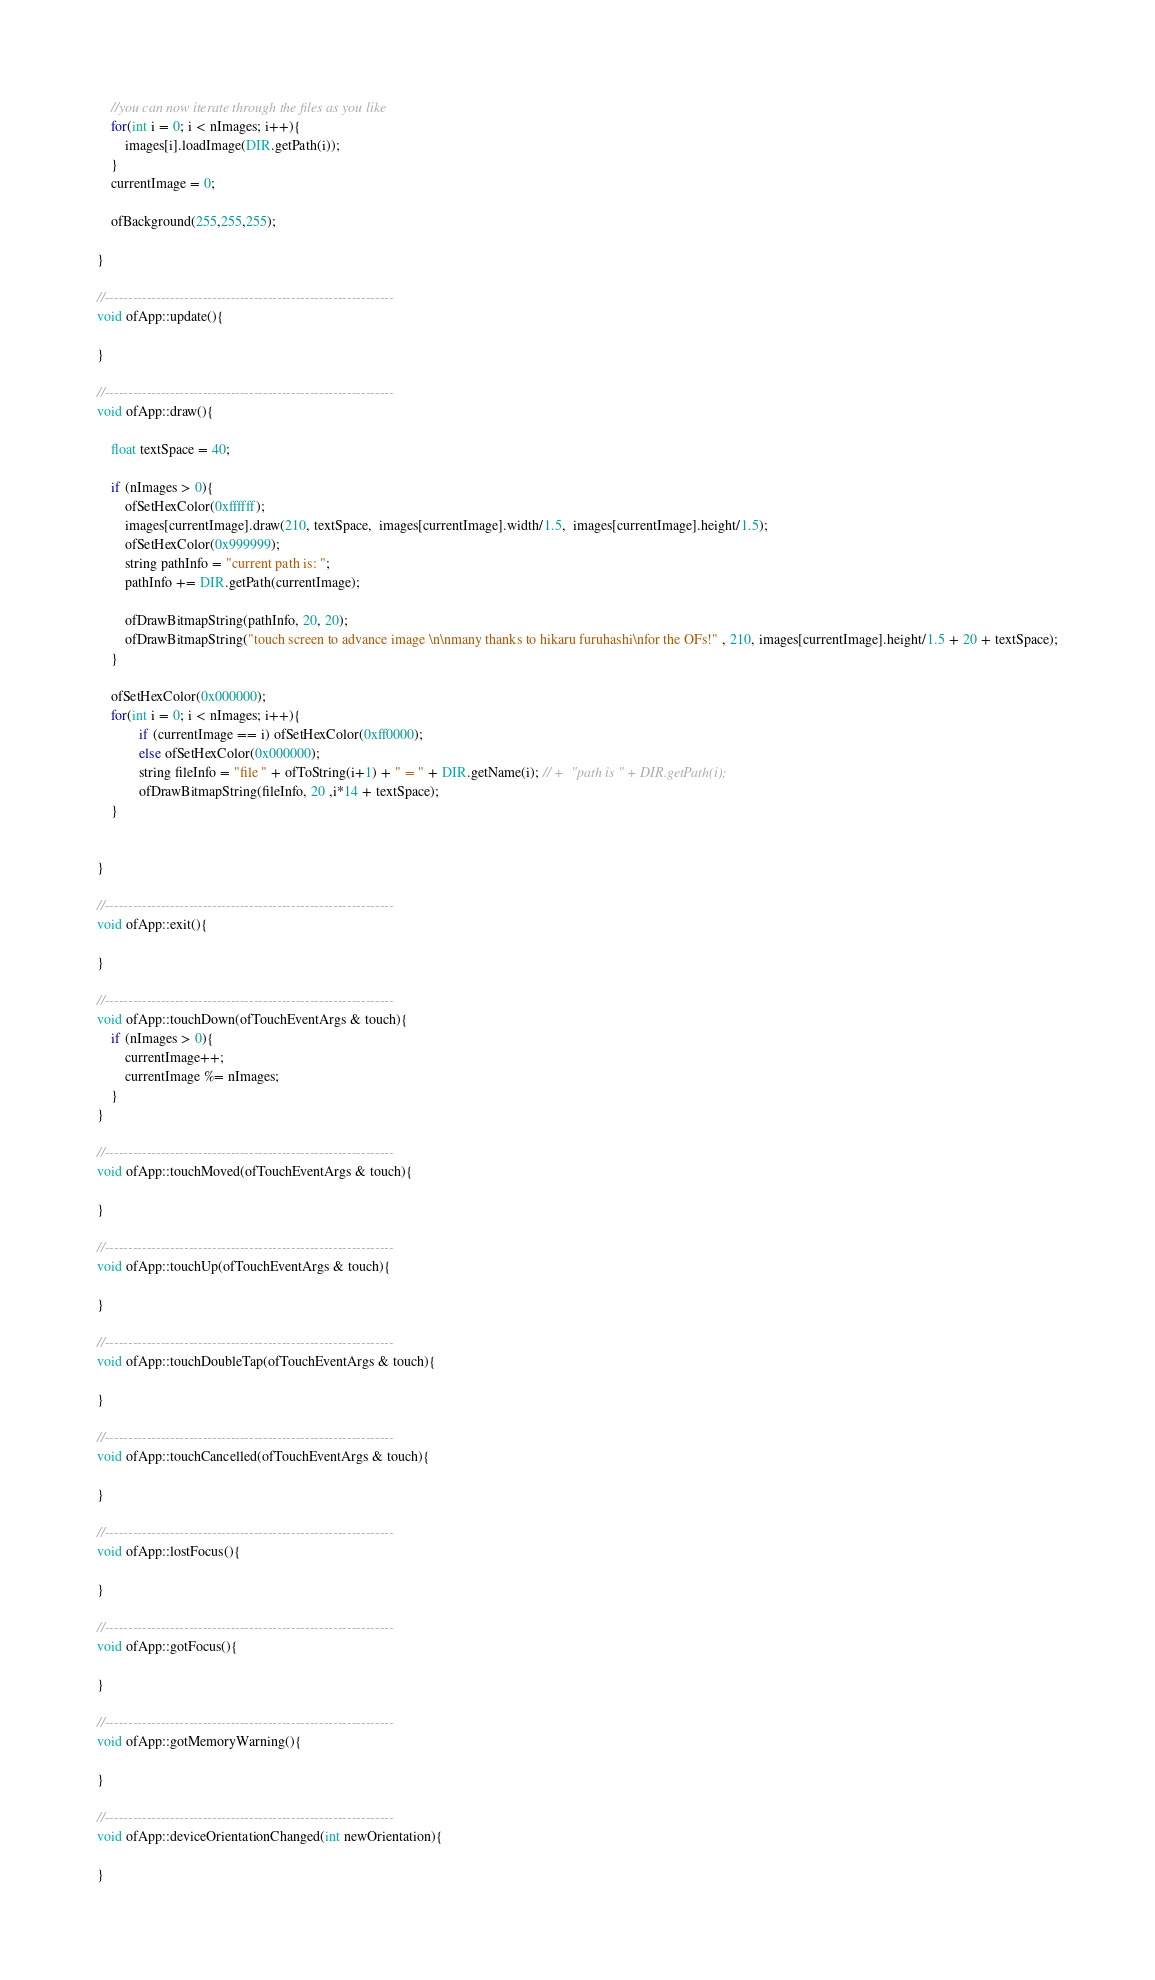Convert code to text. <code><loc_0><loc_0><loc_500><loc_500><_ObjectiveC_>    //you can now iterate through the files as you like
    for(int i = 0; i < nImages; i++){
		images[i].loadImage(DIR.getPath(i));
    }
    currentImage = 0;

    ofBackground(255,255,255);

}

//--------------------------------------------------------------
void ofApp::update(){

}

//--------------------------------------------------------------
void ofApp::draw(){
	
	float textSpace = 40;
	
    if (nImages > 0){
        ofSetHexColor(0xffffff);
        images[currentImage].draw(210, textSpace,  images[currentImage].width/1.5,  images[currentImage].height/1.5);
        ofSetHexColor(0x999999);
        string pathInfo = "current path is: ";
		pathInfo += DIR.getPath(currentImage);
				
		ofDrawBitmapString(pathInfo, 20, 20);
		ofDrawBitmapString("touch screen to advance image \n\nmany thanks to hikaru furuhashi\nfor the OFs!" , 210, images[currentImage].height/1.5 + 20 + textSpace);
    }

    ofSetHexColor(0x000000);
    for(int i = 0; i < nImages; i++){
            if (currentImage == i) ofSetHexColor(0xff0000);
            else ofSetHexColor(0x000000);
            string fileInfo = "file " + ofToString(i+1) + " = " + DIR.getName(i); // +  "path is " + DIR.getPath(i);
            ofDrawBitmapString(fileInfo, 20 ,i*14 + textSpace);
    }

	
}

//--------------------------------------------------------------
void ofApp::exit(){

}

//--------------------------------------------------------------
void ofApp::touchDown(ofTouchEventArgs & touch){
	if (nImages > 0){
		currentImage++;
		currentImage %= nImages;
	}
}

//--------------------------------------------------------------
void ofApp::touchMoved(ofTouchEventArgs & touch){

}

//--------------------------------------------------------------
void ofApp::touchUp(ofTouchEventArgs & touch){

}

//--------------------------------------------------------------
void ofApp::touchDoubleTap(ofTouchEventArgs & touch){

}

//--------------------------------------------------------------
void ofApp::touchCancelled(ofTouchEventArgs & touch){
    
}

//--------------------------------------------------------------
void ofApp::lostFocus(){

}

//--------------------------------------------------------------
void ofApp::gotFocus(){

}

//--------------------------------------------------------------
void ofApp::gotMemoryWarning(){

}

//--------------------------------------------------------------
void ofApp::deviceOrientationChanged(int newOrientation){

}
</code> 